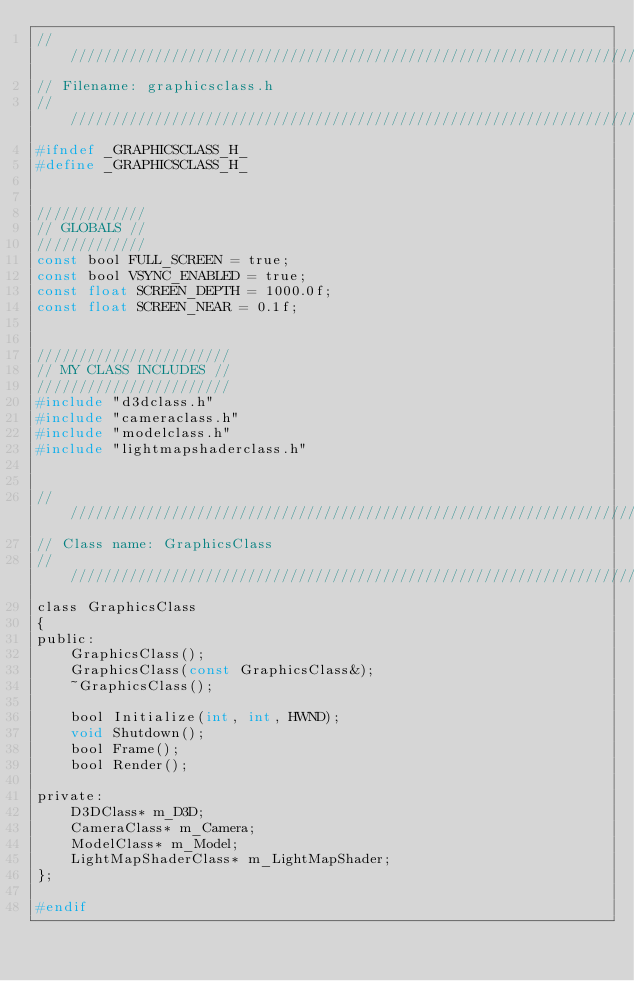Convert code to text. <code><loc_0><loc_0><loc_500><loc_500><_C_>////////////////////////////////////////////////////////////////////////////////
// Filename: graphicsclass.h
////////////////////////////////////////////////////////////////////////////////
#ifndef _GRAPHICSCLASS_H_
#define _GRAPHICSCLASS_H_


/////////////
// GLOBALS //
/////////////
const bool FULL_SCREEN = true;
const bool VSYNC_ENABLED = true;
const float SCREEN_DEPTH = 1000.0f;
const float SCREEN_NEAR = 0.1f;


///////////////////////
// MY CLASS INCLUDES //
///////////////////////
#include "d3dclass.h"
#include "cameraclass.h"
#include "modelclass.h"
#include "lightmapshaderclass.h"


////////////////////////////////////////////////////////////////////////////////
// Class name: GraphicsClass
////////////////////////////////////////////////////////////////////////////////
class GraphicsClass
{
public:
	GraphicsClass();
	GraphicsClass(const GraphicsClass&);
	~GraphicsClass();

	bool Initialize(int, int, HWND);
	void Shutdown();
	bool Frame();
	bool Render();

private:
	D3DClass* m_D3D;
	CameraClass* m_Camera;
	ModelClass* m_Model;
	LightMapShaderClass* m_LightMapShader;
};

#endif</code> 